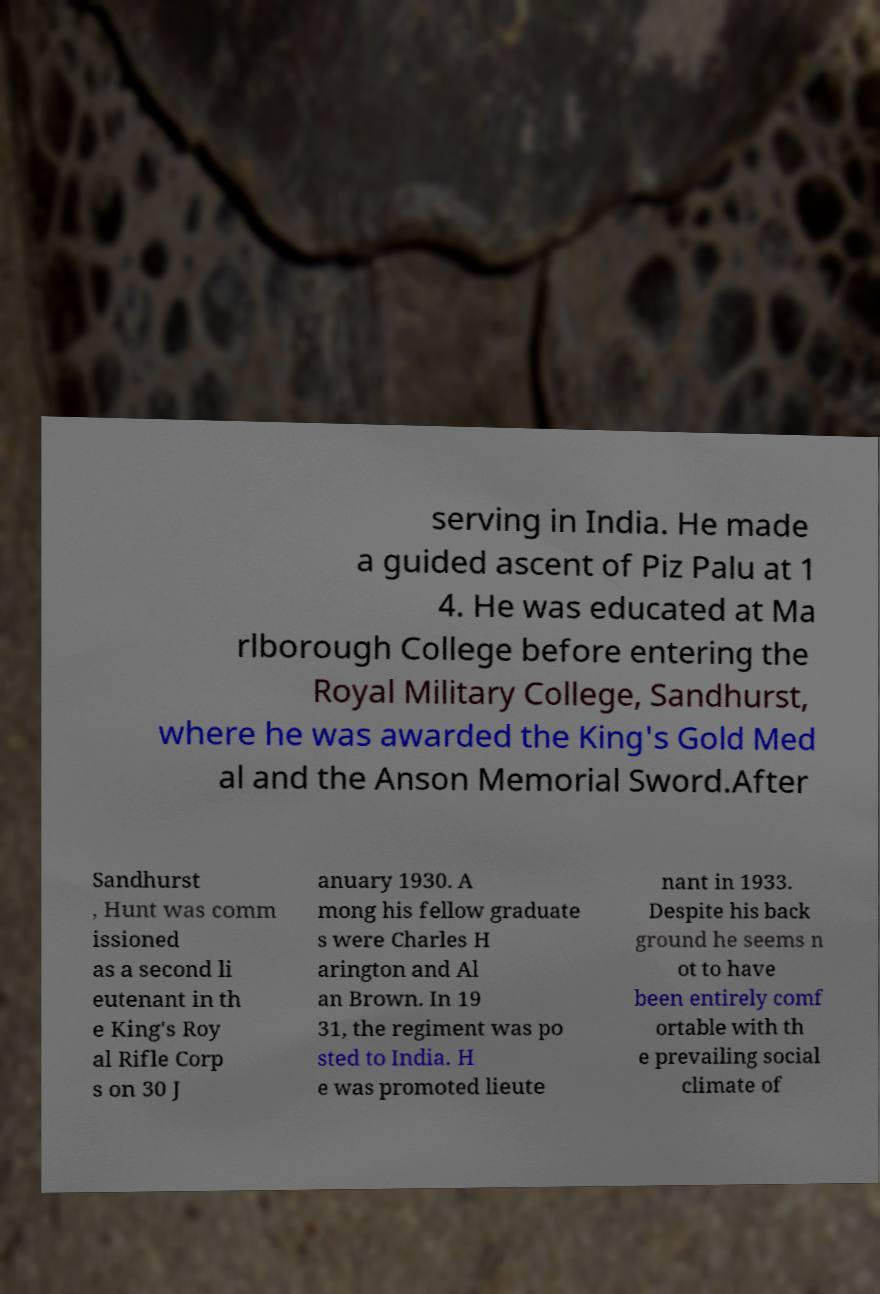Can you accurately transcribe the text from the provided image for me? serving in India. He made a guided ascent of Piz Palu at 1 4. He was educated at Ma rlborough College before entering the Royal Military College, Sandhurst, where he was awarded the King's Gold Med al and the Anson Memorial Sword.After Sandhurst , Hunt was comm issioned as a second li eutenant in th e King's Roy al Rifle Corp s on 30 J anuary 1930. A mong his fellow graduate s were Charles H arington and Al an Brown. In 19 31, the regiment was po sted to India. H e was promoted lieute nant in 1933. Despite his back ground he seems n ot to have been entirely comf ortable with th e prevailing social climate of 